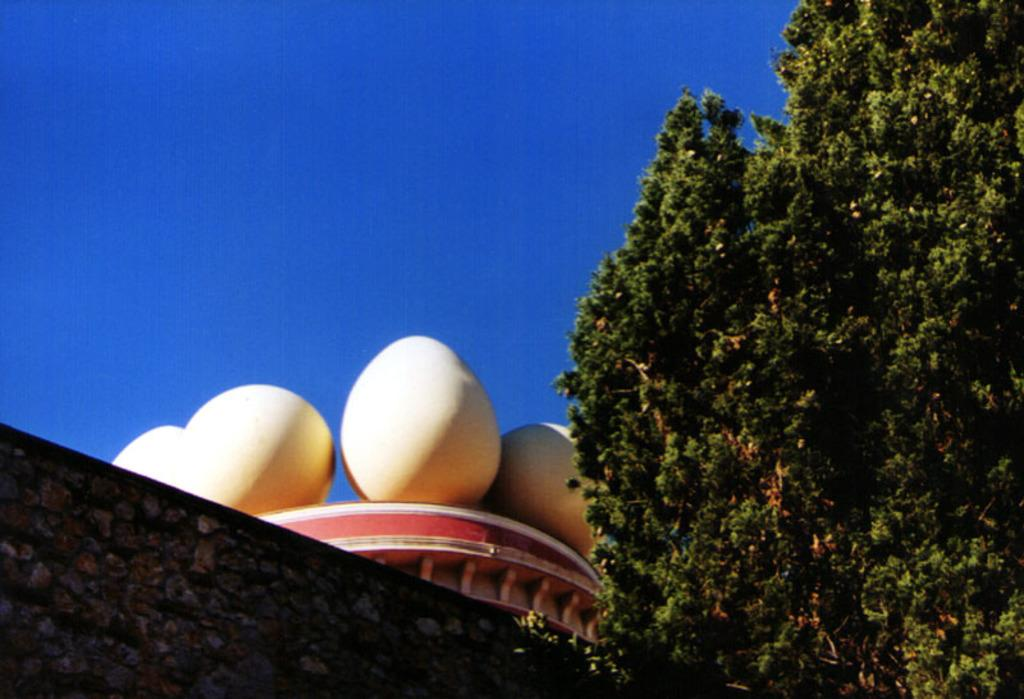What type of structure can be seen in the image? There is a rock wall and a building in the image. What natural element is present in the image? There is a tree in the image. What is visible in the background of the image? The sky is visible in the image. What type of rhythm can be heard coming from the tree in the image? There is no sound or rhythm associated with the tree in the image. How many spiders are visible on the rock wall in the image? There are no spiders visible on the rock wall in the image. 